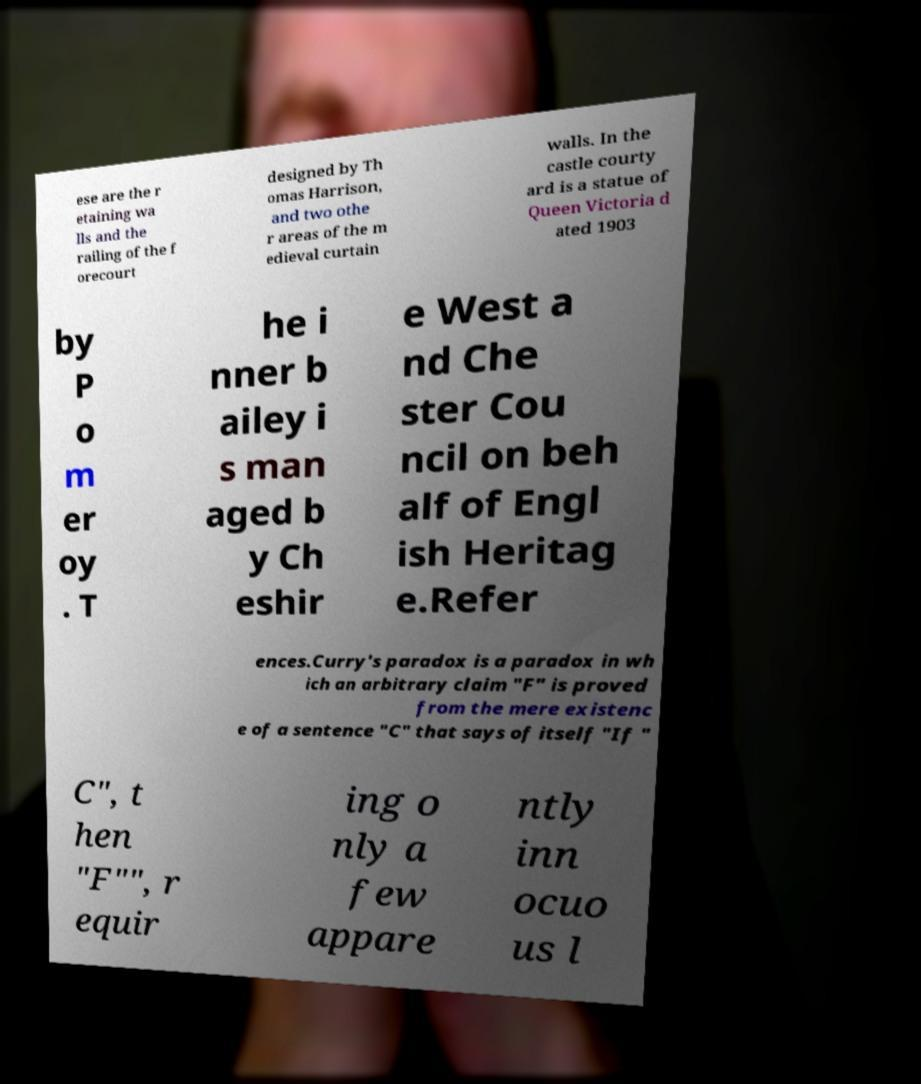Could you extract and type out the text from this image? ese are the r etaining wa lls and the railing of the f orecourt designed by Th omas Harrison, and two othe r areas of the m edieval curtain walls. In the castle courty ard is a statue of Queen Victoria d ated 1903 by P o m er oy . T he i nner b ailey i s man aged b y Ch eshir e West a nd Che ster Cou ncil on beh alf of Engl ish Heritag e.Refer ences.Curry's paradox is a paradox in wh ich an arbitrary claim "F" is proved from the mere existenc e of a sentence "C" that says of itself "If " C", t hen "F"", r equir ing o nly a few appare ntly inn ocuo us l 